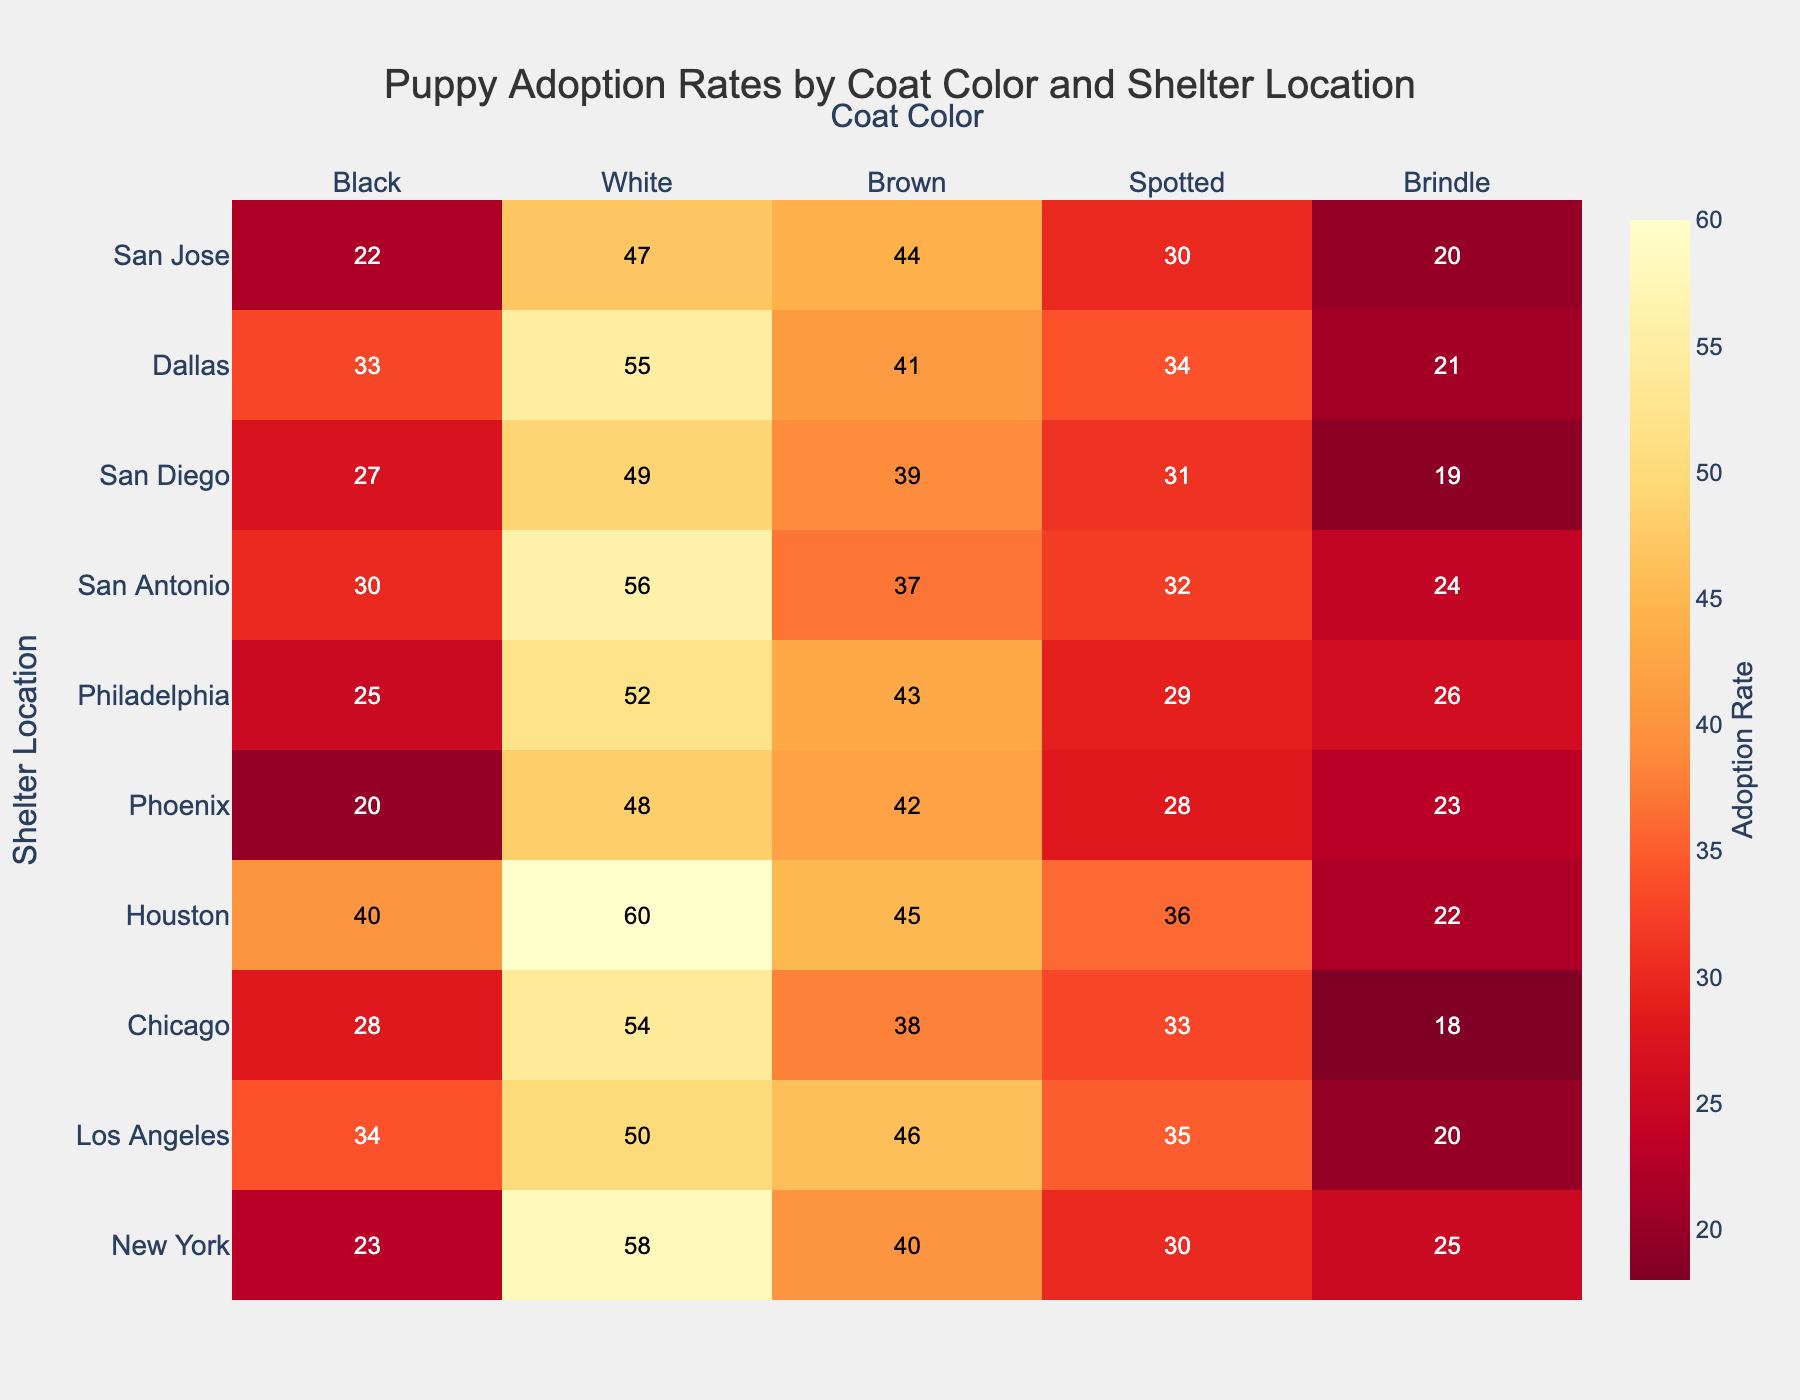What is the adoption rate for black coat color puppies in Los Angeles? Look at the cell where the row for "Los Angeles" intersects with the column for "Black". The adoption rate is the number in that cell.
Answer: 34 Which shelter location has the highest adoption rate for brindle coat color puppies? Look at the column for "Brindle" and find the highest number. Then, check which row (shelter location) it belongs to.
Answer: New York Which coat color has the lowest adoption rate in Phoenix? Find the row for "Phoenix" and identify the smallest number in that row. Then, check which coat color column it belongs to.
Answer: Black What is the average adoption rate for spotted coat color puppies across all shelter locations? Sum the adoption rates for "Spotted" from all rows and divide by the number of shelter locations. Calculation: (30+35+33+36+28+29+32+31+34+30)/10. So, (30+35+33+36+28+29+32+31+34+30)/10 = 31.8
Answer: 31.8 Is the adoption rate for brown coat color puppies higher in San Antonio or Dallas? Compare the number in the "Brown" column for "San Antonio" and "Dallas". The adoption rate in San Antonio is 37 and in Dallas is 41.
Answer: Dallas What is the difference in adoption rates for spotted coat color puppies between New York and Houston? Subtract the adoption rate for "Spotted" in New York from the adoption rate for "Spotted" in Houston. Calculation: 36 - 30 = 6
Answer: 6 Which shelter location has the lowest adoption rate for white coat color puppies? Look at the column for "White" and find the smallest number. Then, check which row (shelter location) it belongs to.
Answer: Phoenix Which coat color has the highest average adoption rate across all shelter locations? Calculate the average of each coat color's adoption rates across all shelters. Then, find the highest average. Black: (23+34+28+40+20+25+30+27+33+22)/10 = 28.2 White: (58+50+54+60+48+52+56+49+55+47)/10 = 52.9 Brown: (40+46+38+45+42+43+37+39+41+44)/10 = 41.5 Spotted: (30+35+33+36+28+29+32+31+34+30)/10 = 31.8 Brindle: (25+20+18+22+23+26+24+19+21+20)/10 = 21.8 The highest average is for White (52.9).
Answer: White Is the adoption rate for brindle coat color puppies in Chicago above or below the average adoption rate for brindle coat color puppies across all locations? Calculate the average adoption rate for "Brindle" across all locations. Then, compare it to Chicago's adoption rate for "Brindle". Chicago's rate is 18; average is 21.8.
Answer: Below Which coat color has the second highest overall adoption rate in Houston? Find the row for "Houston" and identify the second largest number in that row. Then, check which coat color column it belongs to. Order: 60 (White), 45 (Brown), 40 (Black), 36 (Spotted), 22 (Brindle). The second highest is "Brown".
Answer: Brown 